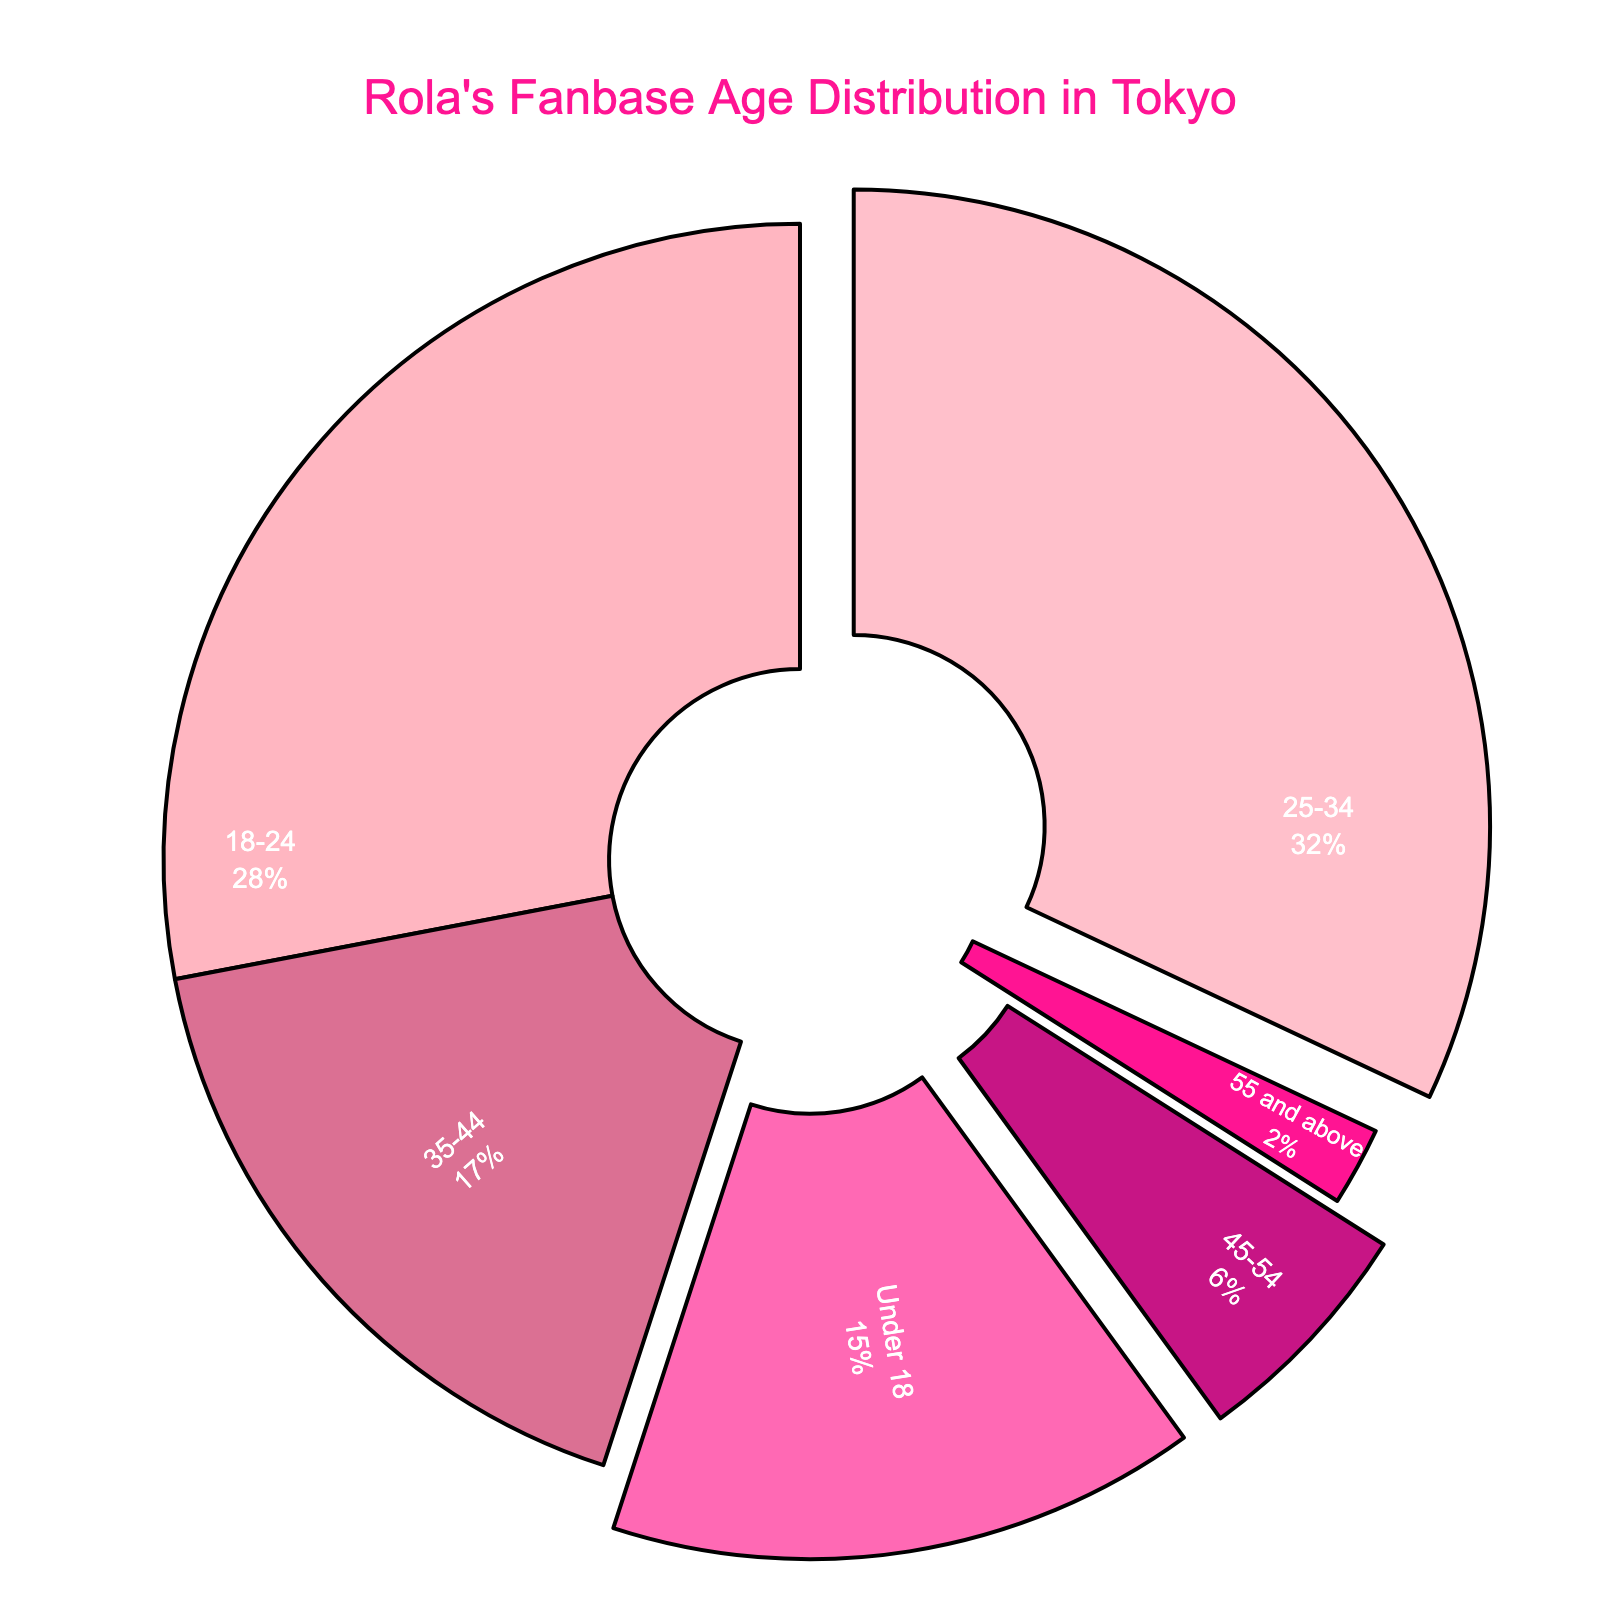What percentage of Rola's fanbase in Tokyo is between 18-44 years old? Add the percentages of the age groups 18-24, 25-34, and 35-44. Therefore, the sum is 28% + 32% + 17% = 77%.
Answer: 77% Which age group has the smallest percentage of Rola's fanbase in Tokyo? The smallest percentage is marked under the age group "55 and above," which is 2%.
Answer: 55 and above How much more popular is Rola among the 25-34 age group compared to the 45-54 age group? Subtract the percentage of the 45-54 age group from the 25-34 age group: 32% - 6% = 26%.
Answer: 26% Is the percentage of fans under 18 or fans 35-44 greater? Compare the percentages: Under 18 (15%) and 35-44 (17%). Since 17% is greater than 15%, the 35-44 age group has a higher percentage.
Answer: 35-44 What is the total percentage of Rola's fanbase in Tokyo that is 45 years old or older? Add the percentages of the 45-54 and 55 and above age groups: 6% + 2% = 8%.
Answer: 8% Which age group has the highest percentage of Rola's fanbase in Tokyo? The highest percentage is in the 25-34 age group with 32%.
Answer: 25-34 How many age groups constitute more than 10% of Rola's fanbase in Tokyo? Identify the age groups with percentages above 10%: Under 18 (15%), 18-24 (28%), 25-34 (32%), and 35-44 (17%). There are four such groups.
Answer: 4 